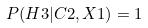<formula> <loc_0><loc_0><loc_500><loc_500>P ( H 3 | C 2 , X 1 ) = 1</formula> 